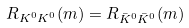Convert formula to latex. <formula><loc_0><loc_0><loc_500><loc_500>R _ { K ^ { 0 } K ^ { 0 } } ( m ) = R _ { \bar { K } ^ { 0 } \bar { K } ^ { 0 } } ( m )</formula> 